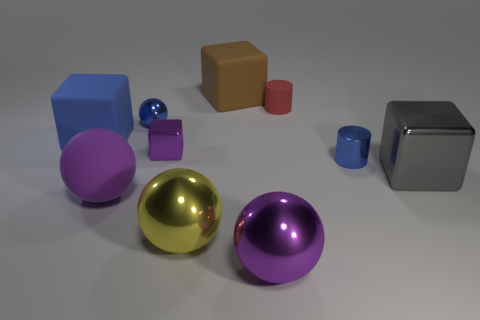Subtract all spheres. How many objects are left? 6 Add 4 cyan spheres. How many cyan spheres exist? 4 Subtract 0 brown spheres. How many objects are left? 10 Subtract all gray metallic cubes. Subtract all matte cubes. How many objects are left? 7 Add 1 purple matte balls. How many purple matte balls are left? 2 